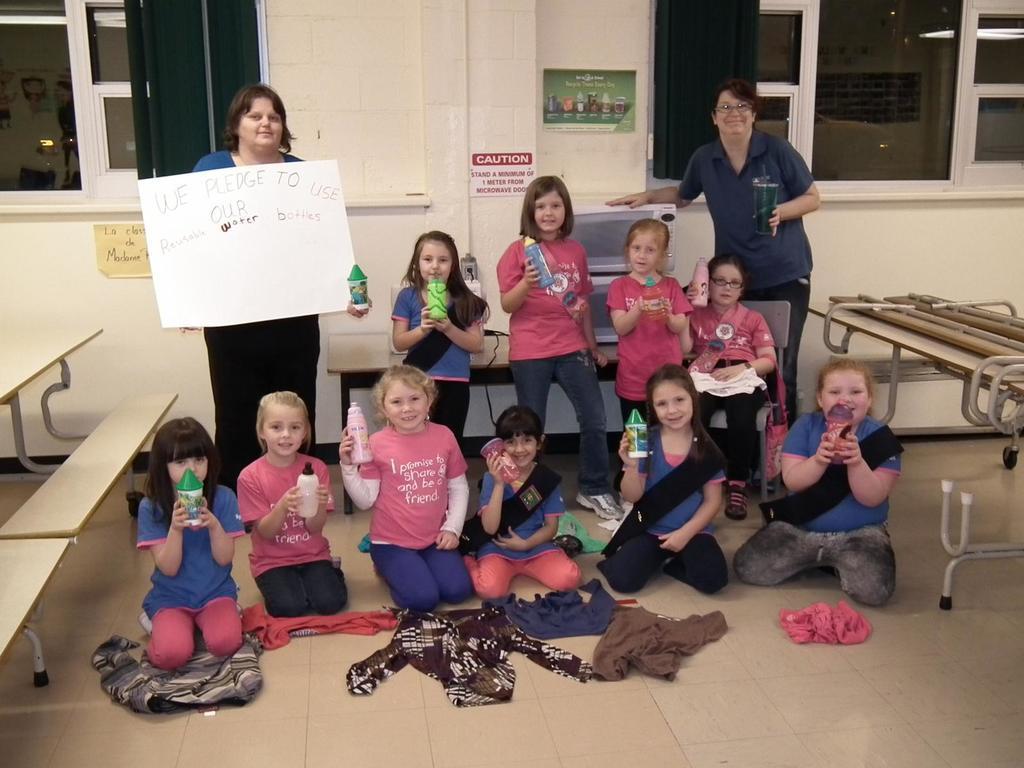How would you summarize this image in a sentence or two? In this picture we can see a group of people are sitting some people are standing and the woman is holding a board. On the left side of the people there are benches and behind the people there is a wall with glass windows. 